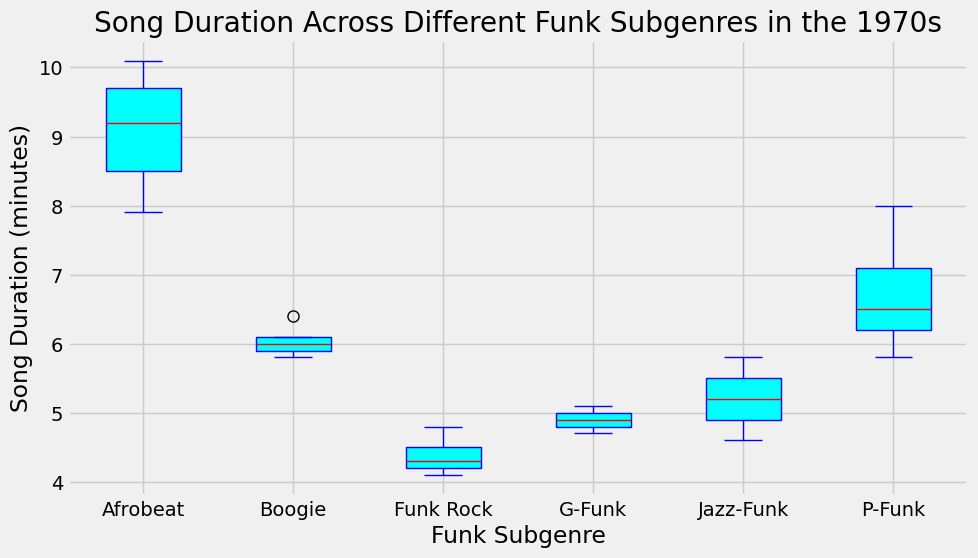Which funk subgenre has the longest median song duration? Look at the red lines within each box representing the median song duration. The red line for Afrobeat is the highest among all subgenres.
Answer: Afrobeat How does the interquartile range (IQR) of Funk Rock compare to P-Funk? The IQR is the range between the lower quartile (bottom box edge) and upper quartile (top box edge). Funk Rock has a smaller IQR compared to P-Funk because Funk Rock's box is shorter.
Answer: Funk Rock's IQR is smaller Which subgenre has the smallest range of song durations? The range is the difference between the maximum and minimum values (whiskers' extents). Funk Rock has the shortest whiskers, indicating the smallest range.
Answer: Funk Rock Is the median song duration for Boogie higher than for G-Funk? Compare the red lines inside the boxes for Boogie and G-Funk. The red line inside Boogie's box is slightly higher than that for G-Funk.
Answer: Yes What is the approximate difference between the median song durations of P-Funk and Jazz-Funk? Identify the red lines inside the boxes for P-Funk and Jazz-Funk. The median of P-Funk is around 6.5, and that of Jazz-Funk is around 5.2. The difference is 6.5 - 5.2.
Answer: Approximately 1.3 Which subgenre has the most outliers, and how can you tell? Outliers are shown as orange dots. P-Funk has outliers visible as dots outside the whiskers, indicating it has the most outliers.
Answer: P-Funk What is the maximum song duration for G-Funk? The maximum value is indicated by the top whisker of the G-Funk box plot. It appears to be around 5.1 minutes.
Answer: 5.1 minutes How does the median song duration for Afrobeat compare to Boogie? Compare the median (red lines) of Afrobeat and Boogie. Afrobeat's median is higher than Boogie's.
Answer: Afrobeat's median is higher Are there any subgenres with overlapping interquartile ranges (IQRs)? Look for boxes that overlap vertically. P-Funk and Boogie, as well as Jazz-Funk and Boogie, have overlapping boxes, indicating overlapping IQRs.
Answer: Yes Which subgenre shows the greatest variability in song durations? Variability can be inferred from the length of the box and whiskers. Afrobeat has the longest whiskers and a relatively large box, indicating high variability.
Answer: Afrobeat 